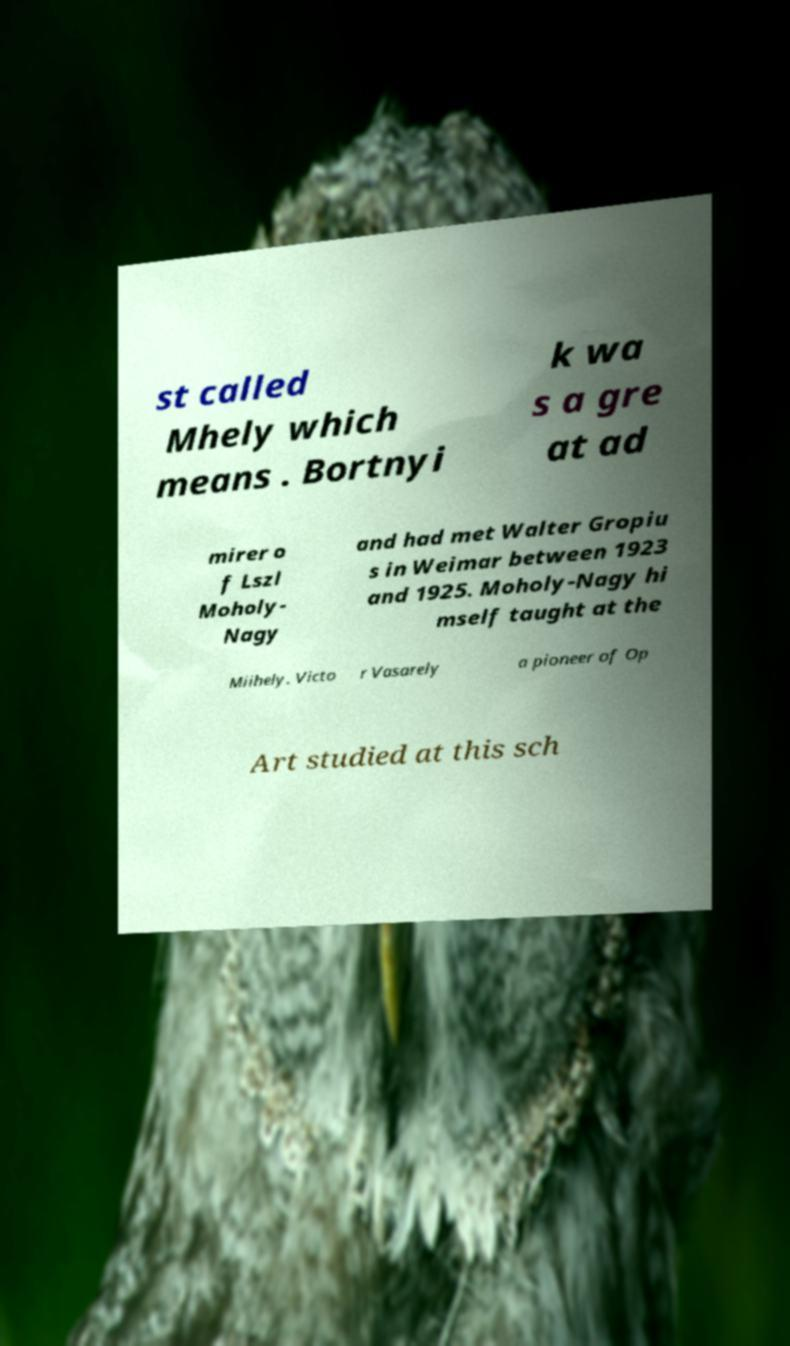Please identify and transcribe the text found in this image. st called Mhely which means . Bortnyi k wa s a gre at ad mirer o f Lszl Moholy- Nagy and had met Walter Gropiu s in Weimar between 1923 and 1925. Moholy-Nagy hi mself taught at the Miihely. Victo r Vasarely a pioneer of Op Art studied at this sch 